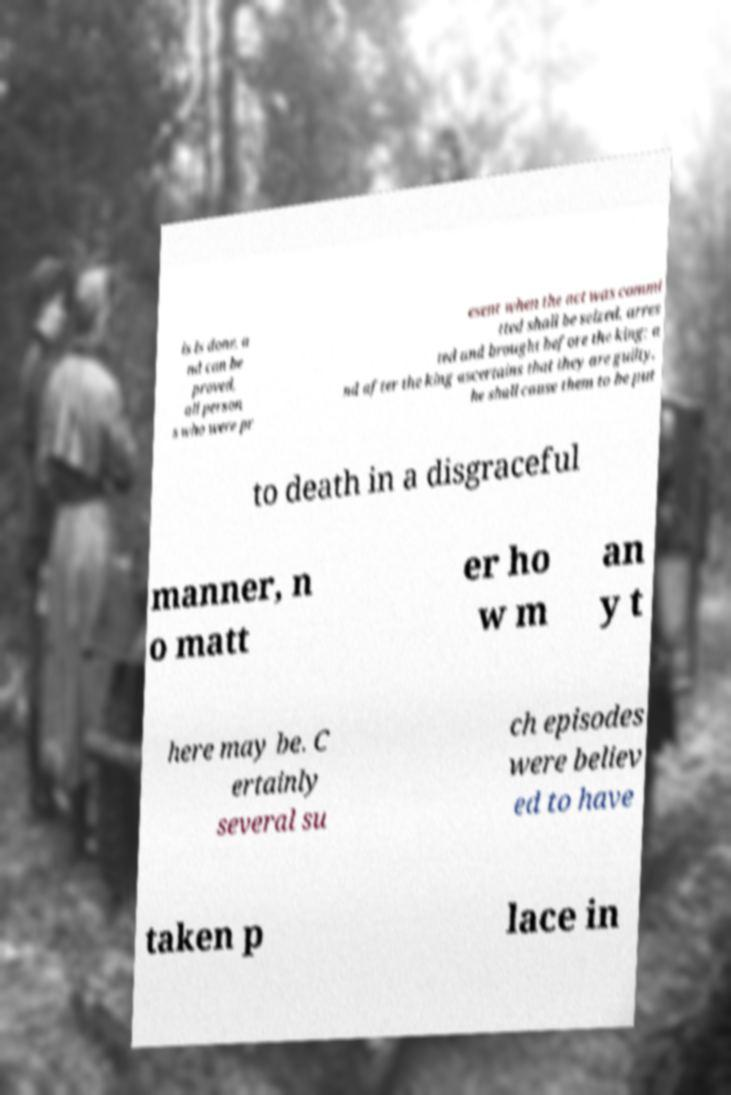For documentation purposes, I need the text within this image transcribed. Could you provide that? is is done, a nd can be proved, all person s who were pr esent when the act was commi tted shall be seized, arres ted and brought before the king; a nd after the king ascertains that they are guilty, he shall cause them to be put to death in a disgraceful manner, n o matt er ho w m an y t here may be. C ertainly several su ch episodes were believ ed to have taken p lace in 